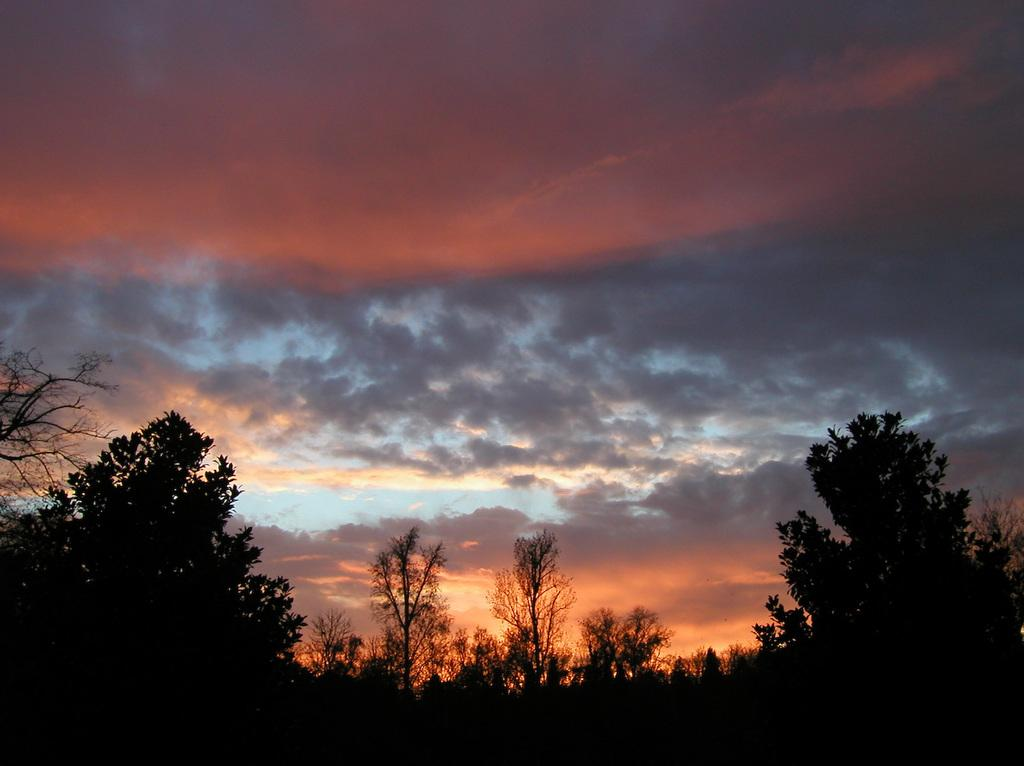What type of vegetation can be seen in the image? There are trees in the front side of the image. What is the color of the sky in the background? There is a red color sunset sky in the background. What else can be seen in the sky besides the sunset? Clouds are visible in the sky. Can you tell me about the historical significance of the bag in the image? There is no bag present in the image, so it is not possible to discuss its historical significance. Is there an owl visible in the image? There is no owl present in the image. 